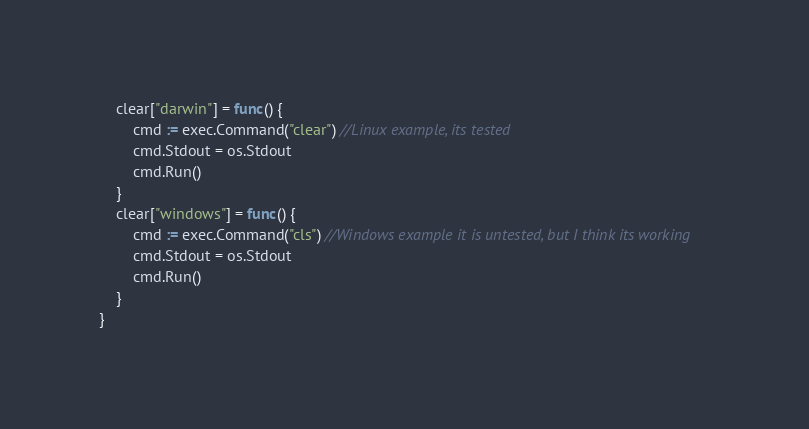Convert code to text. <code><loc_0><loc_0><loc_500><loc_500><_Go_>	clear["darwin"] = func() {
		cmd := exec.Command("clear") //Linux example, its tested
		cmd.Stdout = os.Stdout
		cmd.Run()
	}
	clear["windows"] = func() {
		cmd := exec.Command("cls") //Windows example it is untested, but I think its working
		cmd.Stdout = os.Stdout
		cmd.Run()
	}
}
</code> 